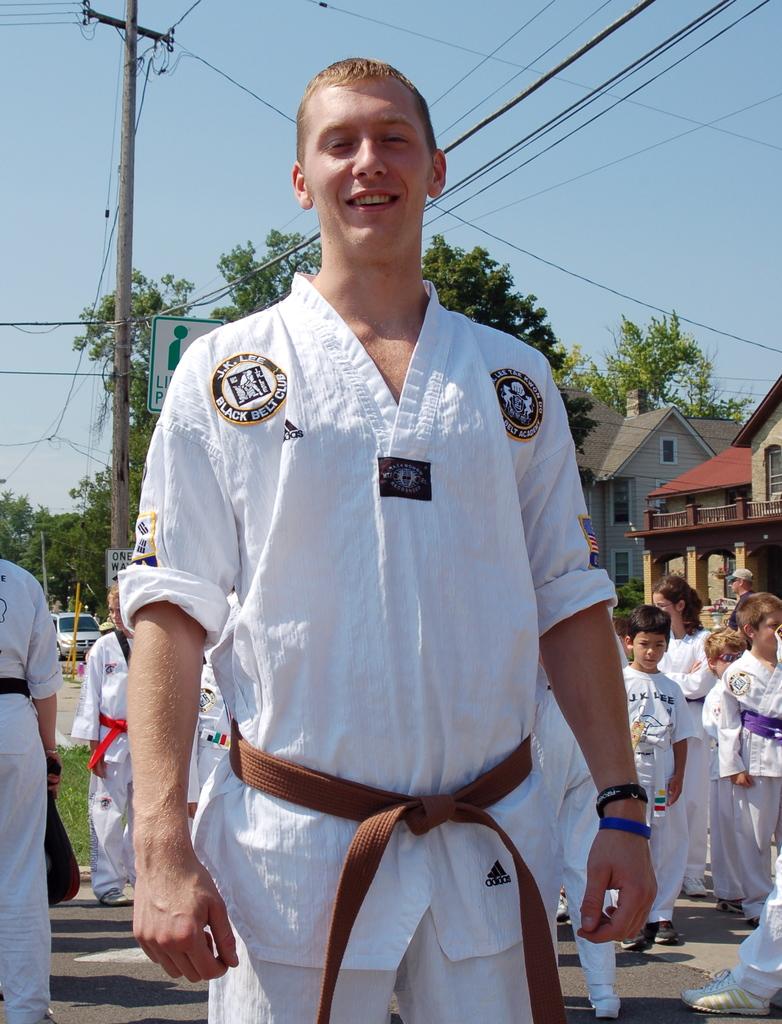What color belt does the man's patch say?
Keep it short and to the point. Black. What brand is the outfit?
Offer a terse response. Adidas. 